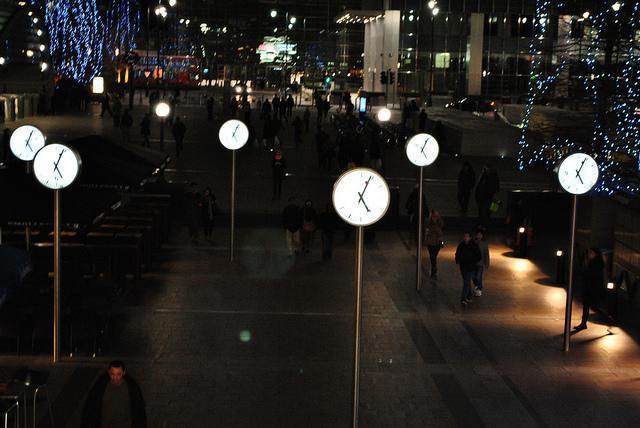How many clocks are there?
Give a very brief answer. 6. How many people can be seen?
Give a very brief answer. 2. 